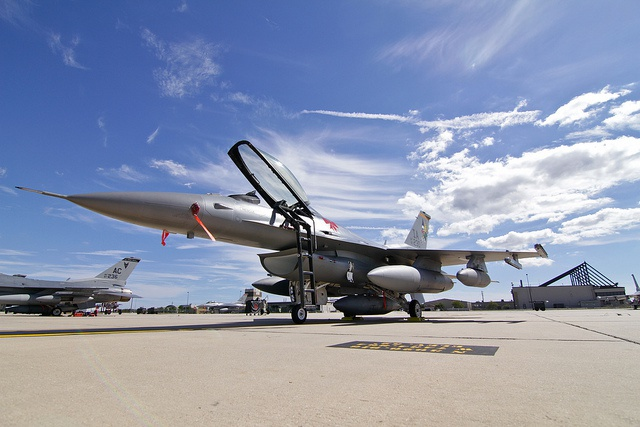Describe the objects in this image and their specific colors. I can see airplane in blue, black, gray, darkgray, and lightgray tones, airplane in blue, black, darkgray, and gray tones, and airplane in blue, gray, black, darkgray, and purple tones in this image. 